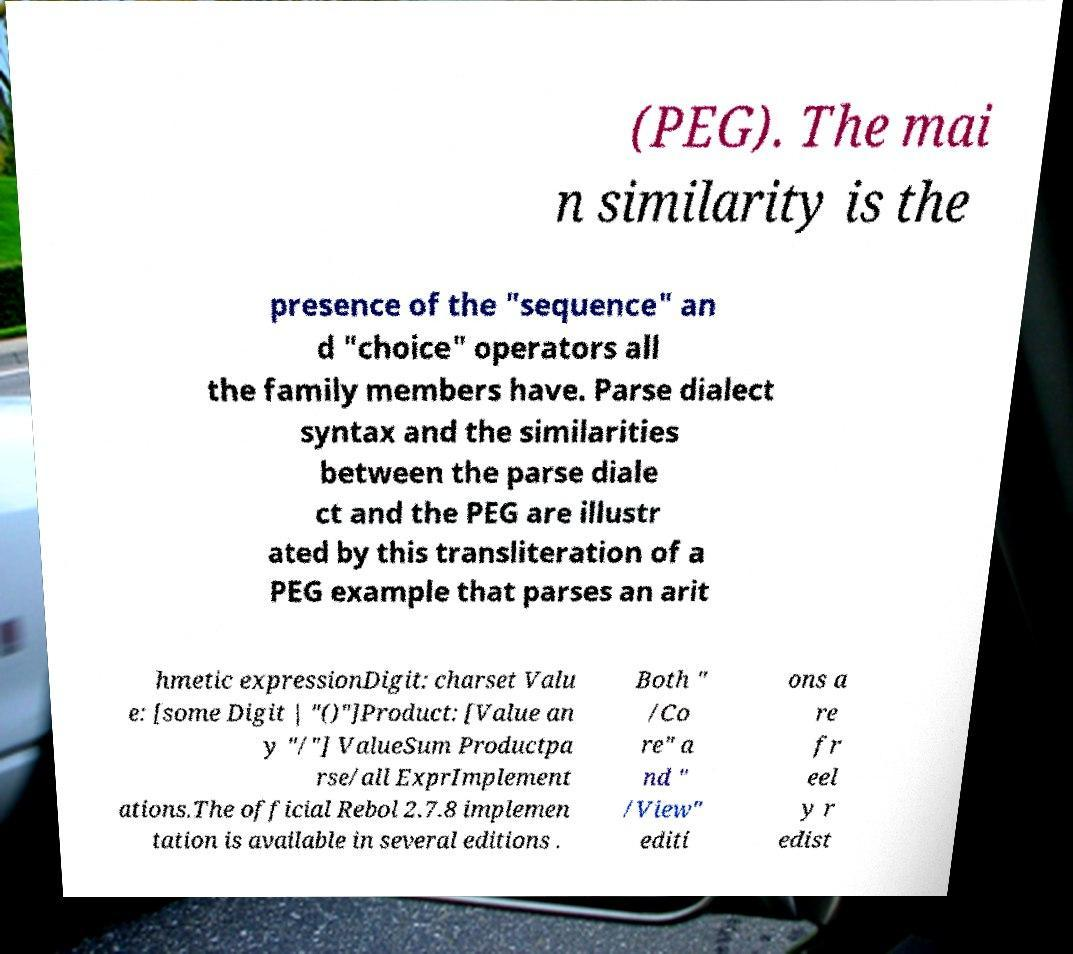Can you read and provide the text displayed in the image?This photo seems to have some interesting text. Can you extract and type it out for me? (PEG). The mai n similarity is the presence of the "sequence" an d "choice" operators all the family members have. Parse dialect syntax and the similarities between the parse diale ct and the PEG are illustr ated by this transliteration of a PEG example that parses an arit hmetic expressionDigit: charset Valu e: [some Digit | "()"]Product: [Value an y "/"] ValueSum Productpa rse/all ExprImplement ations.The official Rebol 2.7.8 implemen tation is available in several editions . Both " /Co re" a nd " /View" editi ons a re fr eel y r edist 